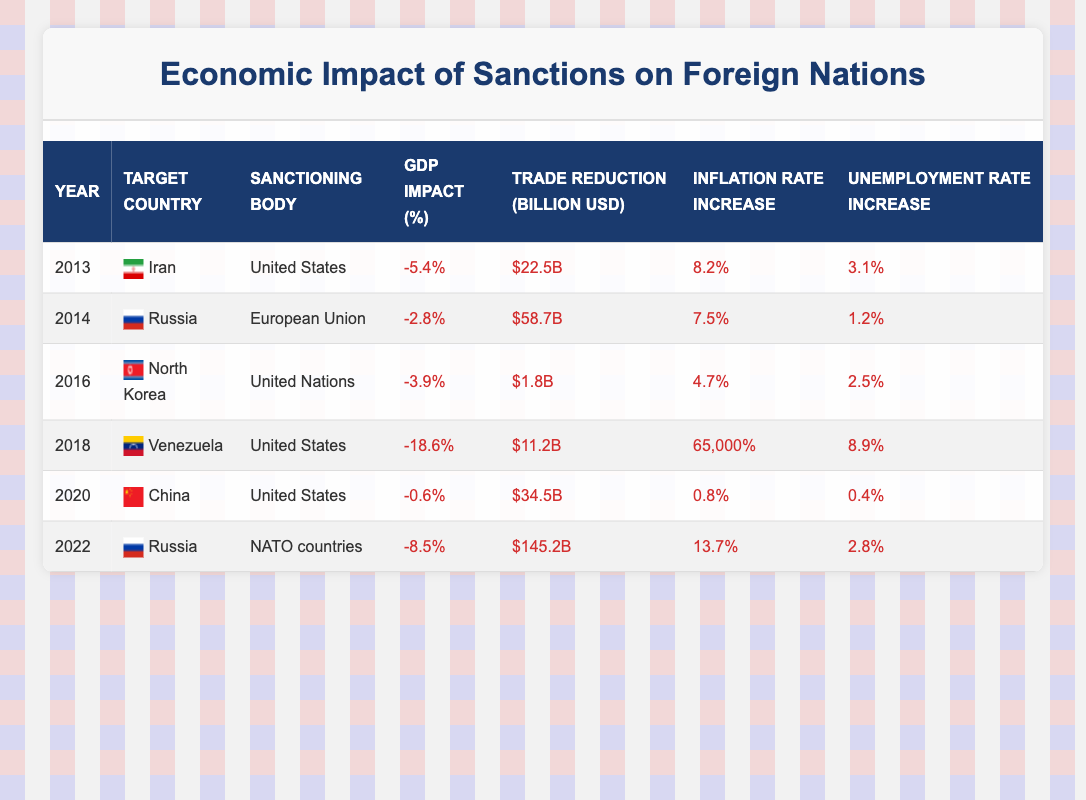What was the GDP impact percentage for Venezuela in 2018? According to the table, the GDP impact percentage for Venezuela in 2018 is listed as -18.6%.
Answer: -18.6% Which country experienced the highest inflation rate increase from sanctions? The table shows the inflation rate increase for each country due to sanctions. Venezuela in 2018 has a staggering inflation rate increase of 65,000%, which is significantly higher than any other entry.
Answer: Venezuela in 2018 What is the total trade reduction in billion USD for Iran and North Korea combined? To find the total trade reduction, add the trade reductions for Iran in 2013 ($22.5B) and North Korea in 2016 ($1.8B): 22.5 + 1.8 = 24.3.
Answer: $24.3B Did sanctions imposed by NATO countries on Russia in 2022 have a greater GDP impact than those imposed by the US on Venezuela in 2018? The table lists the GDP impact percentage for Russia in 2022 as -8.5% and for Venezuela in 2018 as -18.6%. Since -18.6% is lower, this indicates a greater negative impact on Venezuela compared to Russia in 2022.
Answer: No What was the average inflation rate increase for the countries listed from 2013 to 2022? We sum the inflation rate increases: 8.2 + 7.5 + 4.7 + 65000 + 0.8 + 13.7 = 65034.9. Now, divide this by the number of entries: 65034.9 / 6 = 10839.15. The average inflation rate increase is therefore approximately 10839.15%.
Answer: 10839.15% What is the trade reduction difference in billion USD between the highest and lowest values in the table? The highest trade reduction is for Russia in 2022 at $145.2B, and the lowest is for North Korea in 2016 at $1.8B. The difference is calculated as 145.2 - 1.8 = 143.4.
Answer: $143.4B Which country had the highest unemployment rate increase due to sanctions? The table indicates that Venezuela in 2018 had the highest unemployment rate increase at 8.9%, compared to other countries listed which all have lower increases.
Answer: Venezuela in 2018 What is the summary of sanctions imposed on Russia in terms of GDP impact across different years? The table shows that Russia faced sanctions in 2014 with a GDP impact of -2.8% and in 2022 with a GDP impact of -8.5%. This indicates an increasing negative economic impact from sanctions over time.
Answer: GDP impact increased How many years showed a GDP impact worse than -5%? By evaluating the GDP impact percentages in the table, only Venezuela in 2018 (-18.6%) and Russia in 2022 (-8.5%) showed impacts worse than -5%. Therefore, there are 2 years in total.
Answer: 2 years 